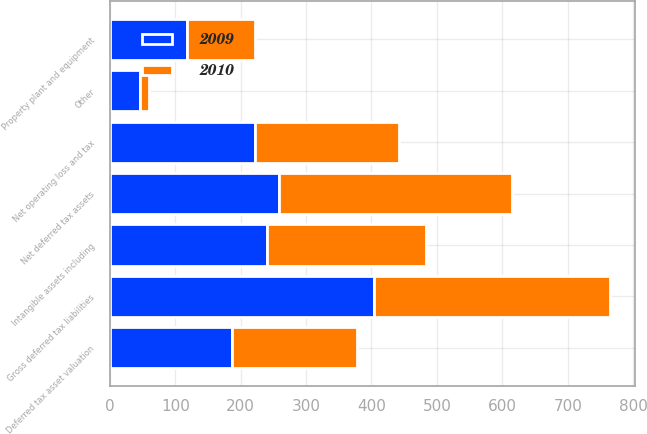<chart> <loc_0><loc_0><loc_500><loc_500><stacked_bar_chart><ecel><fcel>Net operating loss and tax<fcel>Deferred tax asset valuation<fcel>Net deferred tax assets<fcel>Intangible assets including<fcel>Property plant and equipment<fcel>Other<fcel>Gross deferred tax liabilities<nl><fcel>2010<fcel>220<fcel>191<fcel>356<fcel>243<fcel>104<fcel>14<fcel>361<nl><fcel>2009<fcel>222<fcel>187<fcel>259<fcel>240<fcel>118<fcel>46<fcel>404<nl></chart> 